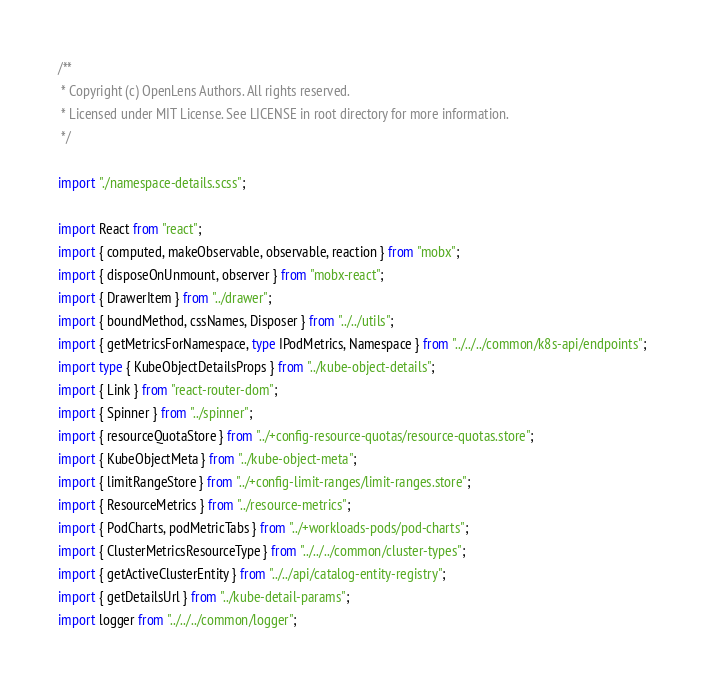<code> <loc_0><loc_0><loc_500><loc_500><_TypeScript_>/**
 * Copyright (c) OpenLens Authors. All rights reserved.
 * Licensed under MIT License. See LICENSE in root directory for more information.
 */

import "./namespace-details.scss";

import React from "react";
import { computed, makeObservable, observable, reaction } from "mobx";
import { disposeOnUnmount, observer } from "mobx-react";
import { DrawerItem } from "../drawer";
import { boundMethod, cssNames, Disposer } from "../../utils";
import { getMetricsForNamespace, type IPodMetrics, Namespace } from "../../../common/k8s-api/endpoints";
import type { KubeObjectDetailsProps } from "../kube-object-details";
import { Link } from "react-router-dom";
import { Spinner } from "../spinner";
import { resourceQuotaStore } from "../+config-resource-quotas/resource-quotas.store";
import { KubeObjectMeta } from "../kube-object-meta";
import { limitRangeStore } from "../+config-limit-ranges/limit-ranges.store";
import { ResourceMetrics } from "../resource-metrics";
import { PodCharts, podMetricTabs } from "../+workloads-pods/pod-charts";
import { ClusterMetricsResourceType } from "../../../common/cluster-types";
import { getActiveClusterEntity } from "../../api/catalog-entity-registry";
import { getDetailsUrl } from "../kube-detail-params";
import logger from "../../../common/logger";</code> 